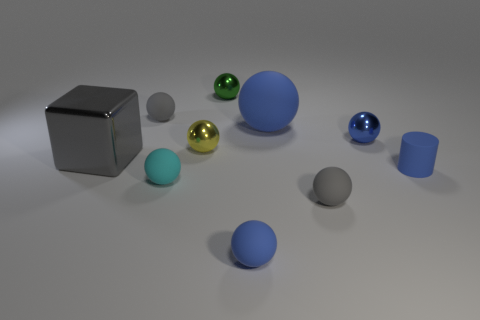Subtract all green cylinders. How many blue spheres are left? 3 Subtract all small cyan balls. How many balls are left? 7 Subtract all cyan balls. How many balls are left? 7 Subtract all gray balls. Subtract all blue cubes. How many balls are left? 6 Subtract all cubes. How many objects are left? 9 Add 3 green spheres. How many green spheres exist? 4 Subtract 0 yellow cylinders. How many objects are left? 10 Subtract all big green cubes. Subtract all small green metallic things. How many objects are left? 9 Add 2 tiny green balls. How many tiny green balls are left? 3 